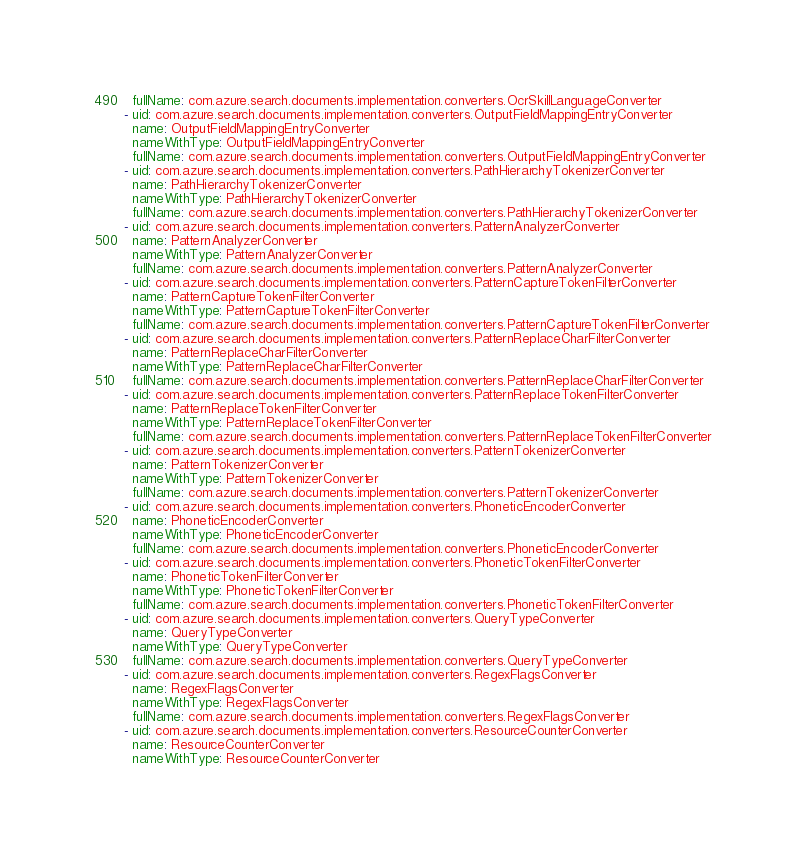Convert code to text. <code><loc_0><loc_0><loc_500><loc_500><_YAML_>  fullName: com.azure.search.documents.implementation.converters.OcrSkillLanguageConverter
- uid: com.azure.search.documents.implementation.converters.OutputFieldMappingEntryConverter
  name: OutputFieldMappingEntryConverter
  nameWithType: OutputFieldMappingEntryConverter
  fullName: com.azure.search.documents.implementation.converters.OutputFieldMappingEntryConverter
- uid: com.azure.search.documents.implementation.converters.PathHierarchyTokenizerConverter
  name: PathHierarchyTokenizerConverter
  nameWithType: PathHierarchyTokenizerConverter
  fullName: com.azure.search.documents.implementation.converters.PathHierarchyTokenizerConverter
- uid: com.azure.search.documents.implementation.converters.PatternAnalyzerConverter
  name: PatternAnalyzerConverter
  nameWithType: PatternAnalyzerConverter
  fullName: com.azure.search.documents.implementation.converters.PatternAnalyzerConverter
- uid: com.azure.search.documents.implementation.converters.PatternCaptureTokenFilterConverter
  name: PatternCaptureTokenFilterConverter
  nameWithType: PatternCaptureTokenFilterConverter
  fullName: com.azure.search.documents.implementation.converters.PatternCaptureTokenFilterConverter
- uid: com.azure.search.documents.implementation.converters.PatternReplaceCharFilterConverter
  name: PatternReplaceCharFilterConverter
  nameWithType: PatternReplaceCharFilterConverter
  fullName: com.azure.search.documents.implementation.converters.PatternReplaceCharFilterConverter
- uid: com.azure.search.documents.implementation.converters.PatternReplaceTokenFilterConverter
  name: PatternReplaceTokenFilterConverter
  nameWithType: PatternReplaceTokenFilterConverter
  fullName: com.azure.search.documents.implementation.converters.PatternReplaceTokenFilterConverter
- uid: com.azure.search.documents.implementation.converters.PatternTokenizerConverter
  name: PatternTokenizerConverter
  nameWithType: PatternTokenizerConverter
  fullName: com.azure.search.documents.implementation.converters.PatternTokenizerConverter
- uid: com.azure.search.documents.implementation.converters.PhoneticEncoderConverter
  name: PhoneticEncoderConverter
  nameWithType: PhoneticEncoderConverter
  fullName: com.azure.search.documents.implementation.converters.PhoneticEncoderConverter
- uid: com.azure.search.documents.implementation.converters.PhoneticTokenFilterConverter
  name: PhoneticTokenFilterConverter
  nameWithType: PhoneticTokenFilterConverter
  fullName: com.azure.search.documents.implementation.converters.PhoneticTokenFilterConverter
- uid: com.azure.search.documents.implementation.converters.QueryTypeConverter
  name: QueryTypeConverter
  nameWithType: QueryTypeConverter
  fullName: com.azure.search.documents.implementation.converters.QueryTypeConverter
- uid: com.azure.search.documents.implementation.converters.RegexFlagsConverter
  name: RegexFlagsConverter
  nameWithType: RegexFlagsConverter
  fullName: com.azure.search.documents.implementation.converters.RegexFlagsConverter
- uid: com.azure.search.documents.implementation.converters.ResourceCounterConverter
  name: ResourceCounterConverter
  nameWithType: ResourceCounterConverter</code> 